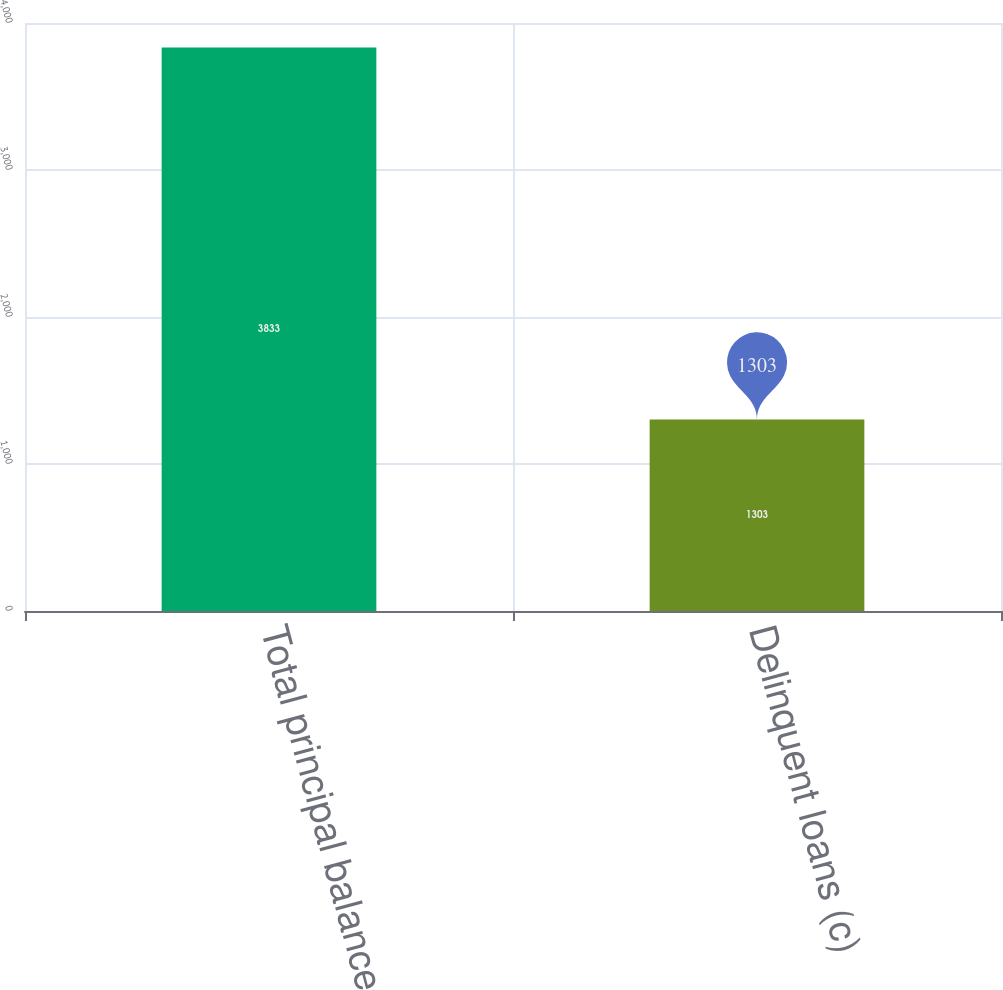<chart> <loc_0><loc_0><loc_500><loc_500><bar_chart><fcel>Total principal balance<fcel>Delinquent loans (c)<nl><fcel>3833<fcel>1303<nl></chart> 